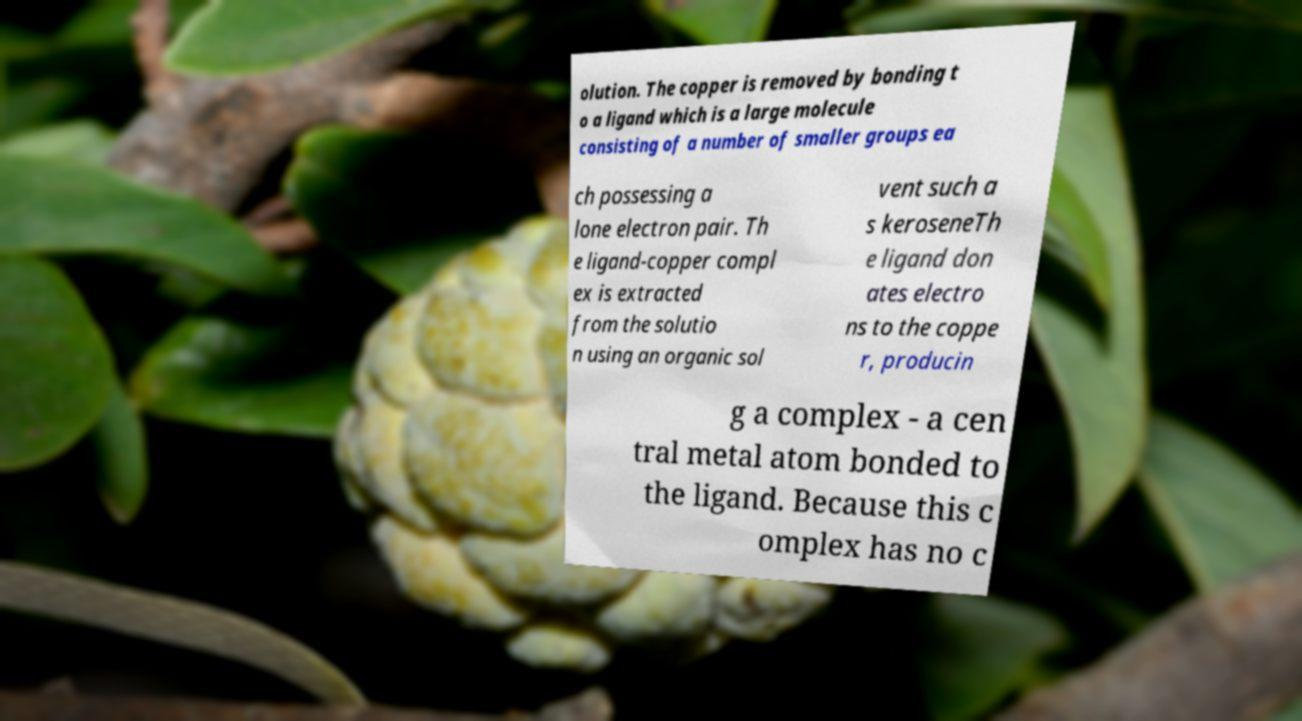Please read and relay the text visible in this image. What does it say? olution. The copper is removed by bonding t o a ligand which is a large molecule consisting of a number of smaller groups ea ch possessing a lone electron pair. Th e ligand-copper compl ex is extracted from the solutio n using an organic sol vent such a s keroseneTh e ligand don ates electro ns to the coppe r, producin g a complex - a cen tral metal atom bonded to the ligand. Because this c omplex has no c 